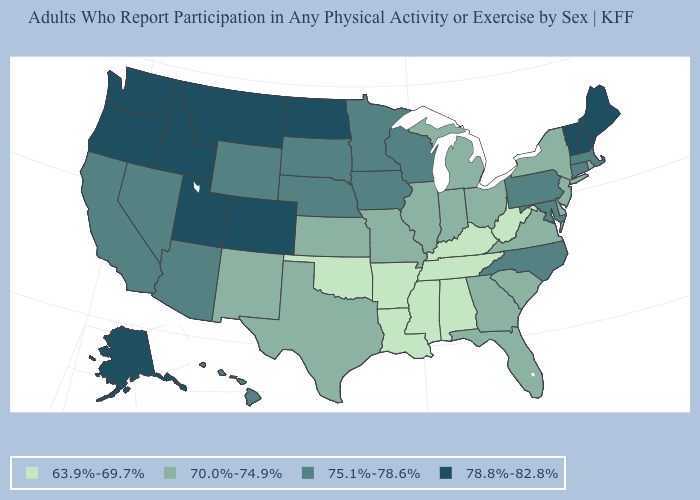Which states have the lowest value in the MidWest?
Quick response, please. Illinois, Indiana, Kansas, Michigan, Missouri, Ohio. What is the lowest value in the USA?
Be succinct. 63.9%-69.7%. What is the lowest value in states that border Ohio?
Short answer required. 63.9%-69.7%. What is the value of New Hampshire?
Answer briefly. 78.8%-82.8%. What is the value of Nevada?
Short answer required. 75.1%-78.6%. Does Texas have a lower value than Tennessee?
Concise answer only. No. Does Michigan have the same value as Missouri?
Write a very short answer. Yes. Is the legend a continuous bar?
Keep it brief. No. Which states have the highest value in the USA?
Short answer required. Alaska, Colorado, Idaho, Maine, Montana, New Hampshire, North Dakota, Oregon, Utah, Vermont, Washington. What is the highest value in states that border New Hampshire?
Answer briefly. 78.8%-82.8%. How many symbols are there in the legend?
Quick response, please. 4. Which states have the lowest value in the West?
Quick response, please. New Mexico. Among the states that border Texas , does Oklahoma have the lowest value?
Concise answer only. Yes. Which states have the highest value in the USA?
Write a very short answer. Alaska, Colorado, Idaho, Maine, Montana, New Hampshire, North Dakota, Oregon, Utah, Vermont, Washington. Is the legend a continuous bar?
Short answer required. No. 